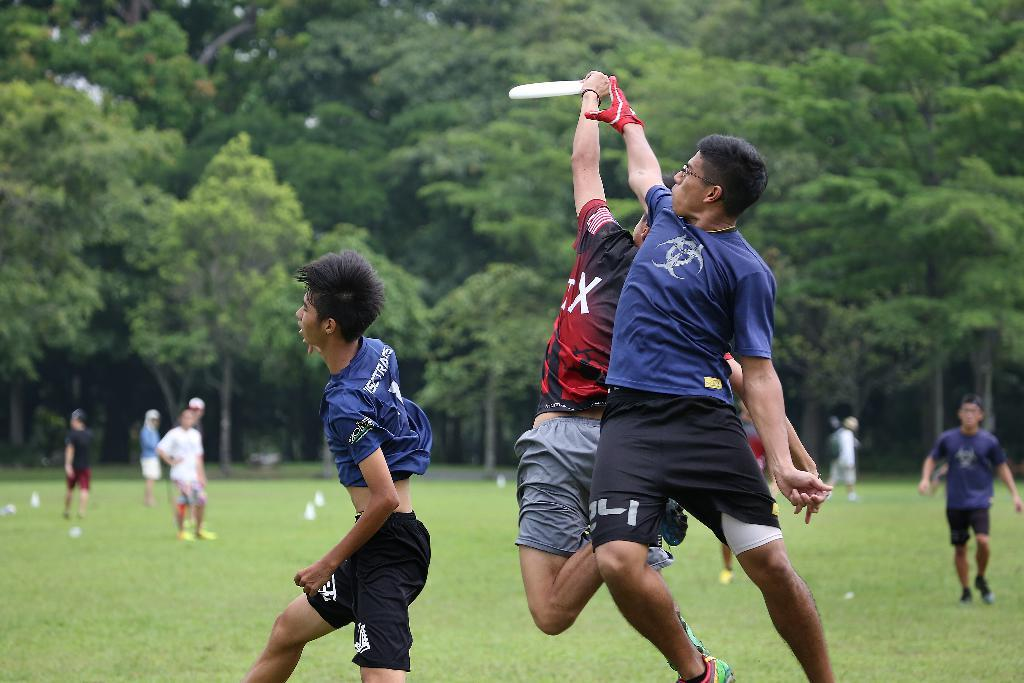Provide a one-sentence caption for the provided image. A person in black and red wearing the letter X leaps to catch a frisbee over a defender in blue. 